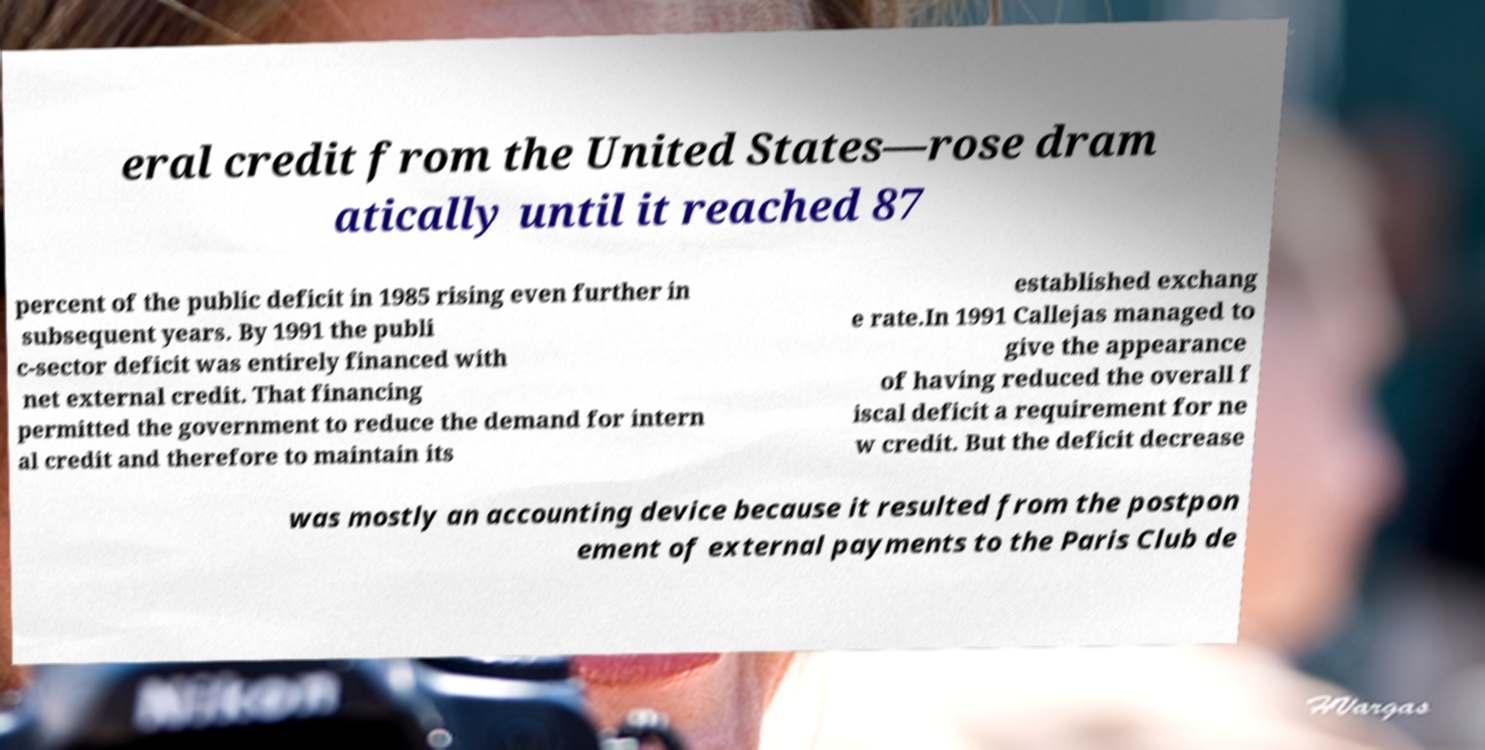Please identify and transcribe the text found in this image. eral credit from the United States—rose dram atically until it reached 87 percent of the public deficit in 1985 rising even further in subsequent years. By 1991 the publi c-sector deficit was entirely financed with net external credit. That financing permitted the government to reduce the demand for intern al credit and therefore to maintain its established exchang e rate.In 1991 Callejas managed to give the appearance of having reduced the overall f iscal deficit a requirement for ne w credit. But the deficit decrease was mostly an accounting device because it resulted from the postpon ement of external payments to the Paris Club de 